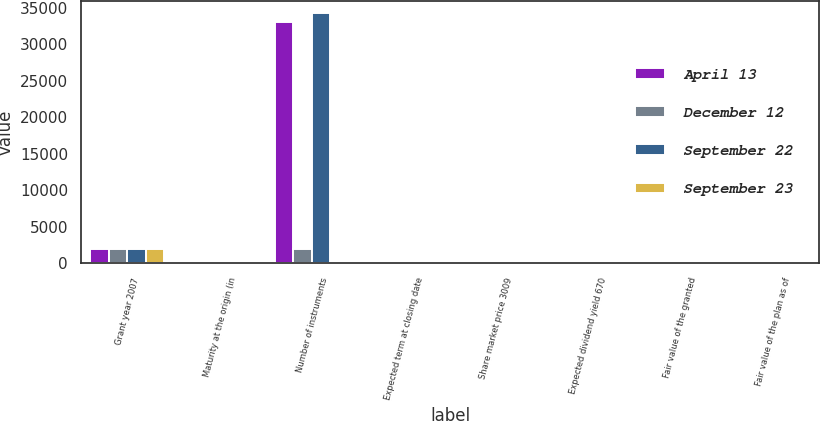Convert chart to OTSL. <chart><loc_0><loc_0><loc_500><loc_500><stacked_bar_chart><ecel><fcel>Grant year 2007<fcel>Maturity at the origin (in<fcel>Number of instruments<fcel>Expected term at closing date<fcel>Share market price 3009<fcel>Expected dividend yield 670<fcel>Fair value of the granted<fcel>Fair value of the plan as of<nl><fcel>April 13<fcel>2006<fcel>0<fcel>33105<fcel>0<fcel>30.09<fcel>6.7<fcel>30.09<fcel>1<nl><fcel>December 12<fcel>2006<fcel>2<fcel>2000<fcel>0<fcel>30.09<fcel>6.7<fcel>30.09<fcel>0.1<nl><fcel>September 22<fcel>2006<fcel>2<fcel>34224<fcel>0<fcel>30.09<fcel>6.7<fcel>30.09<fcel>1<nl><fcel>September 23<fcel>2007<fcel>10<fcel>6.7<fcel>3.8<fcel>30.09<fcel>6.7<fcel>1.41<fcel>0.7<nl></chart> 